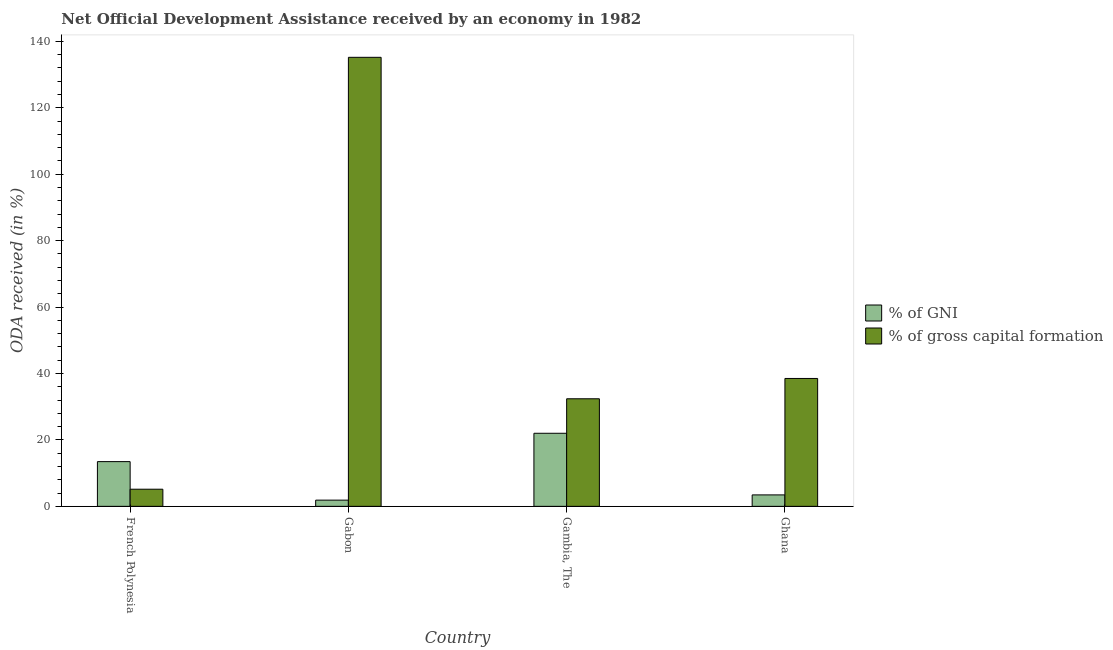How many different coloured bars are there?
Give a very brief answer. 2. How many groups of bars are there?
Give a very brief answer. 4. Are the number of bars per tick equal to the number of legend labels?
Your answer should be very brief. Yes. Are the number of bars on each tick of the X-axis equal?
Give a very brief answer. Yes. What is the label of the 2nd group of bars from the left?
Keep it short and to the point. Gabon. In how many cases, is the number of bars for a given country not equal to the number of legend labels?
Offer a terse response. 0. What is the oda received as percentage of gni in Ghana?
Provide a short and direct response. 3.45. Across all countries, what is the maximum oda received as percentage of gross capital formation?
Provide a succinct answer. 135.18. Across all countries, what is the minimum oda received as percentage of gni?
Offer a terse response. 1.87. In which country was the oda received as percentage of gross capital formation maximum?
Offer a terse response. Gabon. In which country was the oda received as percentage of gni minimum?
Provide a succinct answer. Gabon. What is the total oda received as percentage of gross capital formation in the graph?
Offer a terse response. 211.22. What is the difference between the oda received as percentage of gni in Gambia, The and that in Ghana?
Offer a terse response. 18.55. What is the difference between the oda received as percentage of gni in Gambia, The and the oda received as percentage of gross capital formation in Ghana?
Your answer should be very brief. -16.5. What is the average oda received as percentage of gross capital formation per country?
Ensure brevity in your answer.  52.8. What is the difference between the oda received as percentage of gross capital formation and oda received as percentage of gni in Gabon?
Make the answer very short. 133.3. In how many countries, is the oda received as percentage of gni greater than 116 %?
Make the answer very short. 0. What is the ratio of the oda received as percentage of gni in Gambia, The to that in Ghana?
Make the answer very short. 6.38. Is the difference between the oda received as percentage of gni in French Polynesia and Ghana greater than the difference between the oda received as percentage of gross capital formation in French Polynesia and Ghana?
Provide a succinct answer. Yes. What is the difference between the highest and the second highest oda received as percentage of gni?
Your response must be concise. 8.53. What is the difference between the highest and the lowest oda received as percentage of gross capital formation?
Your response must be concise. 130.02. In how many countries, is the oda received as percentage of gross capital formation greater than the average oda received as percentage of gross capital formation taken over all countries?
Your response must be concise. 1. Is the sum of the oda received as percentage of gni in Gabon and Gambia, The greater than the maximum oda received as percentage of gross capital formation across all countries?
Give a very brief answer. No. What does the 2nd bar from the left in French Polynesia represents?
Your answer should be compact. % of gross capital formation. What does the 1st bar from the right in French Polynesia represents?
Offer a very short reply. % of gross capital formation. How many countries are there in the graph?
Provide a short and direct response. 4. What is the difference between two consecutive major ticks on the Y-axis?
Your answer should be compact. 20. Does the graph contain any zero values?
Give a very brief answer. No. How many legend labels are there?
Ensure brevity in your answer.  2. What is the title of the graph?
Provide a succinct answer. Net Official Development Assistance received by an economy in 1982. Does "Under-5(female)" appear as one of the legend labels in the graph?
Ensure brevity in your answer.  No. What is the label or title of the X-axis?
Your response must be concise. Country. What is the label or title of the Y-axis?
Provide a short and direct response. ODA received (in %). What is the ODA received (in %) in % of GNI in French Polynesia?
Your response must be concise. 13.46. What is the ODA received (in %) of % of gross capital formation in French Polynesia?
Your answer should be compact. 5.16. What is the ODA received (in %) of % of GNI in Gabon?
Give a very brief answer. 1.87. What is the ODA received (in %) of % of gross capital formation in Gabon?
Your answer should be compact. 135.18. What is the ODA received (in %) of % of GNI in Gambia, The?
Your answer should be compact. 22. What is the ODA received (in %) of % of gross capital formation in Gambia, The?
Offer a very short reply. 32.39. What is the ODA received (in %) of % of GNI in Ghana?
Give a very brief answer. 3.45. What is the ODA received (in %) of % of gross capital formation in Ghana?
Keep it short and to the point. 38.5. Across all countries, what is the maximum ODA received (in %) of % of GNI?
Offer a terse response. 22. Across all countries, what is the maximum ODA received (in %) of % of gross capital formation?
Your answer should be compact. 135.18. Across all countries, what is the minimum ODA received (in %) of % of GNI?
Provide a succinct answer. 1.87. Across all countries, what is the minimum ODA received (in %) of % of gross capital formation?
Make the answer very short. 5.16. What is the total ODA received (in %) of % of GNI in the graph?
Ensure brevity in your answer.  40.78. What is the total ODA received (in %) in % of gross capital formation in the graph?
Offer a terse response. 211.22. What is the difference between the ODA received (in %) in % of GNI in French Polynesia and that in Gabon?
Provide a short and direct response. 11.59. What is the difference between the ODA received (in %) in % of gross capital formation in French Polynesia and that in Gabon?
Offer a very short reply. -130.02. What is the difference between the ODA received (in %) of % of GNI in French Polynesia and that in Gambia, The?
Offer a very short reply. -8.53. What is the difference between the ODA received (in %) of % of gross capital formation in French Polynesia and that in Gambia, The?
Offer a terse response. -27.23. What is the difference between the ODA received (in %) of % of GNI in French Polynesia and that in Ghana?
Give a very brief answer. 10.02. What is the difference between the ODA received (in %) in % of gross capital formation in French Polynesia and that in Ghana?
Provide a succinct answer. -33.34. What is the difference between the ODA received (in %) of % of GNI in Gabon and that in Gambia, The?
Offer a very short reply. -20.13. What is the difference between the ODA received (in %) in % of gross capital formation in Gabon and that in Gambia, The?
Your response must be concise. 102.79. What is the difference between the ODA received (in %) in % of GNI in Gabon and that in Ghana?
Provide a short and direct response. -1.57. What is the difference between the ODA received (in %) in % of gross capital formation in Gabon and that in Ghana?
Provide a succinct answer. 96.68. What is the difference between the ODA received (in %) of % of GNI in Gambia, The and that in Ghana?
Provide a succinct answer. 18.55. What is the difference between the ODA received (in %) of % of gross capital formation in Gambia, The and that in Ghana?
Offer a terse response. -6.11. What is the difference between the ODA received (in %) of % of GNI in French Polynesia and the ODA received (in %) of % of gross capital formation in Gabon?
Provide a succinct answer. -121.71. What is the difference between the ODA received (in %) of % of GNI in French Polynesia and the ODA received (in %) of % of gross capital formation in Gambia, The?
Provide a short and direct response. -18.92. What is the difference between the ODA received (in %) in % of GNI in French Polynesia and the ODA received (in %) in % of gross capital formation in Ghana?
Your response must be concise. -25.03. What is the difference between the ODA received (in %) of % of GNI in Gabon and the ODA received (in %) of % of gross capital formation in Gambia, The?
Provide a short and direct response. -30.51. What is the difference between the ODA received (in %) in % of GNI in Gabon and the ODA received (in %) in % of gross capital formation in Ghana?
Give a very brief answer. -36.63. What is the difference between the ODA received (in %) of % of GNI in Gambia, The and the ODA received (in %) of % of gross capital formation in Ghana?
Your answer should be compact. -16.5. What is the average ODA received (in %) of % of GNI per country?
Offer a terse response. 10.2. What is the average ODA received (in %) of % of gross capital formation per country?
Provide a succinct answer. 52.8. What is the difference between the ODA received (in %) in % of GNI and ODA received (in %) in % of gross capital formation in French Polynesia?
Your response must be concise. 8.31. What is the difference between the ODA received (in %) in % of GNI and ODA received (in %) in % of gross capital formation in Gabon?
Provide a succinct answer. -133.3. What is the difference between the ODA received (in %) in % of GNI and ODA received (in %) in % of gross capital formation in Gambia, The?
Your answer should be very brief. -10.39. What is the difference between the ODA received (in %) in % of GNI and ODA received (in %) in % of gross capital formation in Ghana?
Your answer should be very brief. -35.05. What is the ratio of the ODA received (in %) of % of GNI in French Polynesia to that in Gabon?
Provide a succinct answer. 7.19. What is the ratio of the ODA received (in %) in % of gross capital formation in French Polynesia to that in Gabon?
Offer a terse response. 0.04. What is the ratio of the ODA received (in %) in % of GNI in French Polynesia to that in Gambia, The?
Offer a terse response. 0.61. What is the ratio of the ODA received (in %) in % of gross capital formation in French Polynesia to that in Gambia, The?
Offer a very short reply. 0.16. What is the ratio of the ODA received (in %) of % of GNI in French Polynesia to that in Ghana?
Ensure brevity in your answer.  3.91. What is the ratio of the ODA received (in %) of % of gross capital formation in French Polynesia to that in Ghana?
Your response must be concise. 0.13. What is the ratio of the ODA received (in %) in % of GNI in Gabon to that in Gambia, The?
Offer a terse response. 0.09. What is the ratio of the ODA received (in %) in % of gross capital formation in Gabon to that in Gambia, The?
Keep it short and to the point. 4.17. What is the ratio of the ODA received (in %) in % of GNI in Gabon to that in Ghana?
Offer a very short reply. 0.54. What is the ratio of the ODA received (in %) in % of gross capital formation in Gabon to that in Ghana?
Your response must be concise. 3.51. What is the ratio of the ODA received (in %) in % of GNI in Gambia, The to that in Ghana?
Provide a short and direct response. 6.38. What is the ratio of the ODA received (in %) of % of gross capital formation in Gambia, The to that in Ghana?
Offer a terse response. 0.84. What is the difference between the highest and the second highest ODA received (in %) of % of GNI?
Provide a short and direct response. 8.53. What is the difference between the highest and the second highest ODA received (in %) in % of gross capital formation?
Give a very brief answer. 96.68. What is the difference between the highest and the lowest ODA received (in %) of % of GNI?
Provide a succinct answer. 20.13. What is the difference between the highest and the lowest ODA received (in %) in % of gross capital formation?
Offer a very short reply. 130.02. 